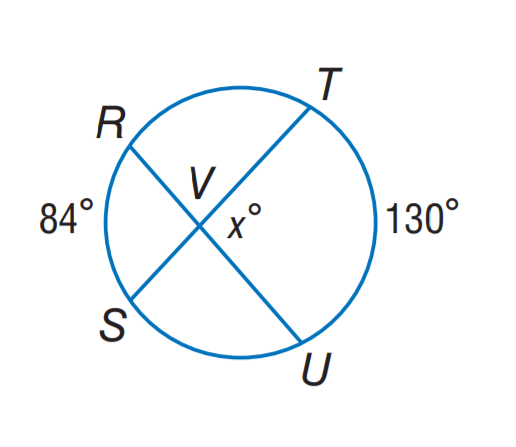Answer the mathemtical geometry problem and directly provide the correct option letter.
Question: Find x.
Choices: A: 84 B: 107 C: 130 D: 158 B 